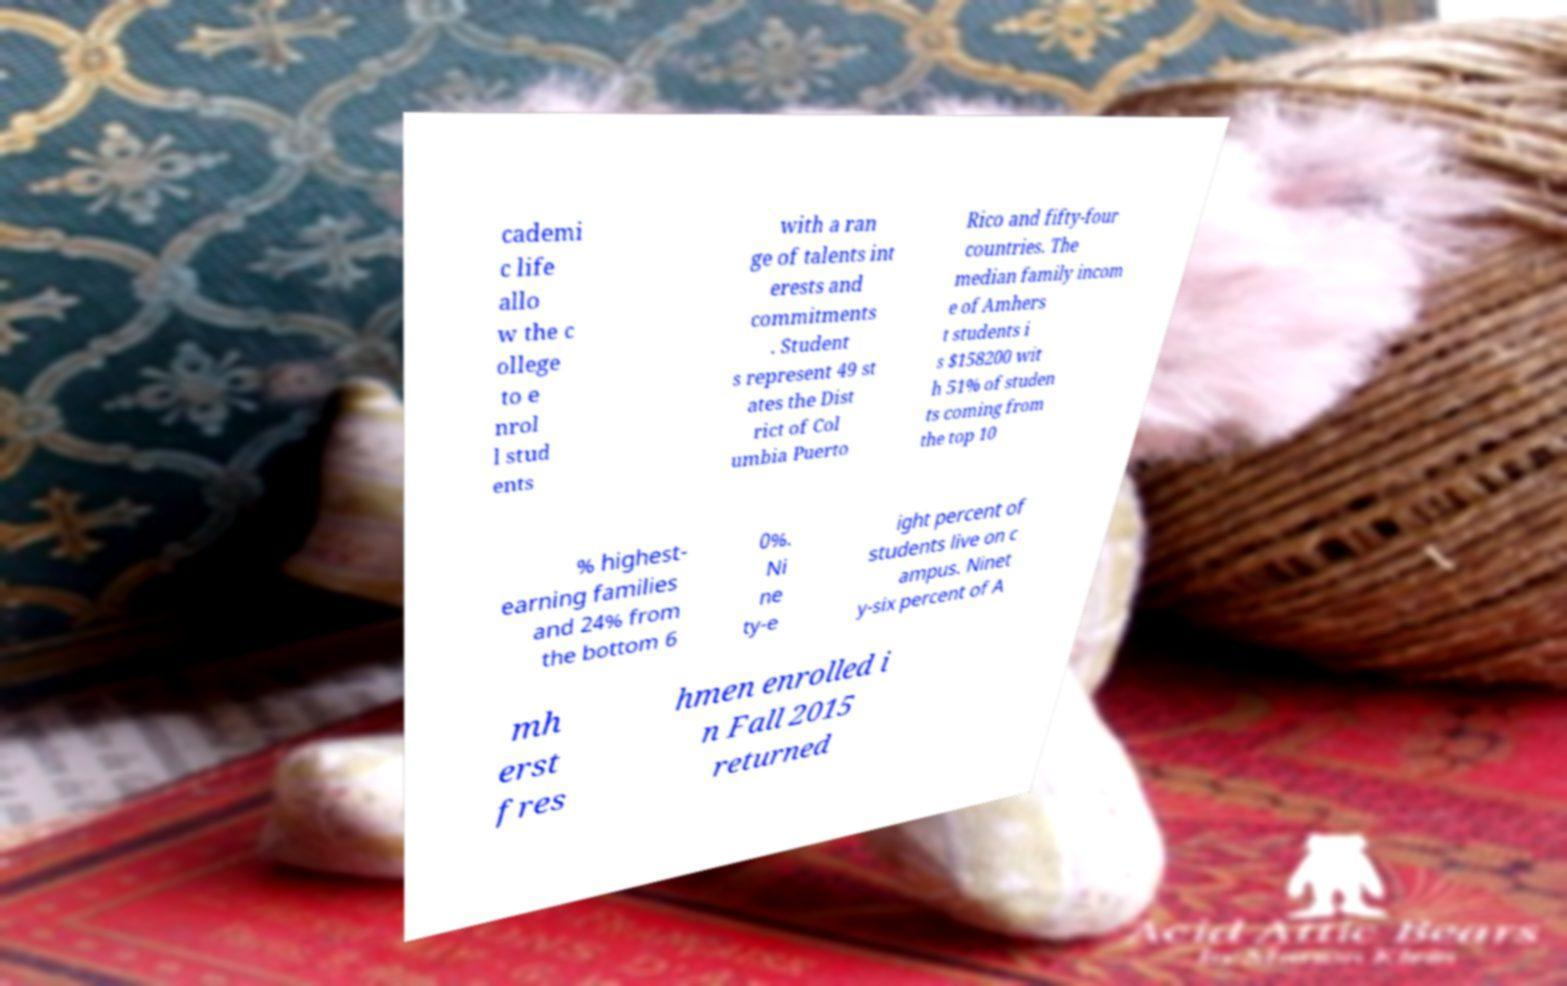What messages or text are displayed in this image? I need them in a readable, typed format. cademi c life allo w the c ollege to e nrol l stud ents with a ran ge of talents int erests and commitments . Student s represent 49 st ates the Dist rict of Col umbia Puerto Rico and fifty-four countries. The median family incom e of Amhers t students i s $158200 wit h 51% of studen ts coming from the top 10 % highest- earning families and 24% from the bottom 6 0%. Ni ne ty-e ight percent of students live on c ampus. Ninet y-six percent of A mh erst fres hmen enrolled i n Fall 2015 returned 